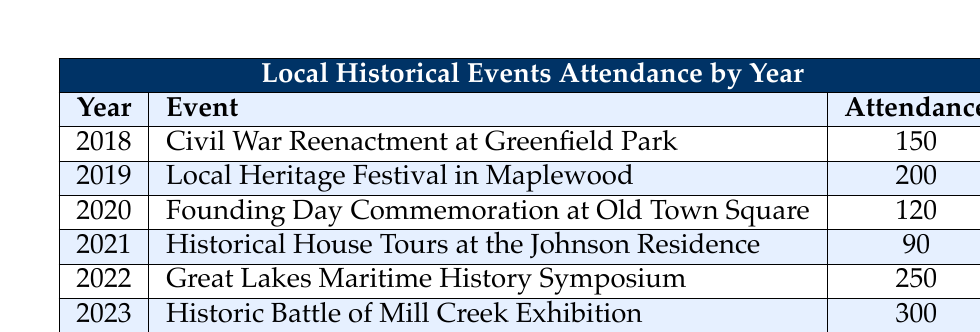What was the attendance at the 2021 historical event? The table indicates that the event in 2021 was the "Historical House Tours at the Johnson Residence," which had an attendance of 90.
Answer: 90 Which event in 2022 had the highest attendance? According to the table, the "Great Lakes Maritime History Symposium" held in 2022 had an attendance of 250, making it the event with the highest attendance that year.
Answer: Great Lakes Maritime History Symposium What was the total attendance across all events listed in the table? The total attendance can be calculated by summing all the attendance values: 150 + 200 + 120 + 90 + 250 + 300 = 1110. The table confirms this total at the bottom.
Answer: 1110 Was the attendance in 2018 greater than that in 2020? By comparing the attendance values, 2018 had 150 attendees (Civil War Reenactment) and 2020 had 120 (Founding Day Commemoration). Since 150 is greater than 120, the statement is true.
Answer: Yes What is the average attendance for the events between 2019 and 2023? To find the average attendance from 2019 to 2023, first identify the attendance values: 200 (2019), 120 (2020), 90 (2021), 250 (2022), and 300 (2023). Summing these values gives 200 + 120 + 90 + 250 + 300 = 960. There are 5 events, so the average is 960 / 5 = 192.
Answer: 192 How many events had an attendance of 200 or more? The table shows that the events with attendance of 200 or more are: "Local Heritage Festival in Maplewood" (200), "Great Lakes Maritime History Symposium" (250), and "Historic Battle of Mill Creek Exhibition" (300). This gives a total of 3 events.
Answer: 3 Was the attendance at the Civil War Reenactment greater than the Historical House Tours? The attendance at the "Civil War Reenactment at Greenfield Park" in 2018 was 150 while the "Historical House Tours at the Johnson Residence" in 2021 had an attendance of 90. Since 150 is greater than 90, it confirms the statement is true.
Answer: Yes What is the difference in attendance between the highest and lowest attended events? The highest attended event is the "Historic Battle of Mill Creek Exhibition" in 2023 with 300 attendees, and the lowest is the "Historical House Tours at the Johnson Residence" in 2021 with 90 attendees. The difference is calculated as 300 - 90 = 210.
Answer: 210 